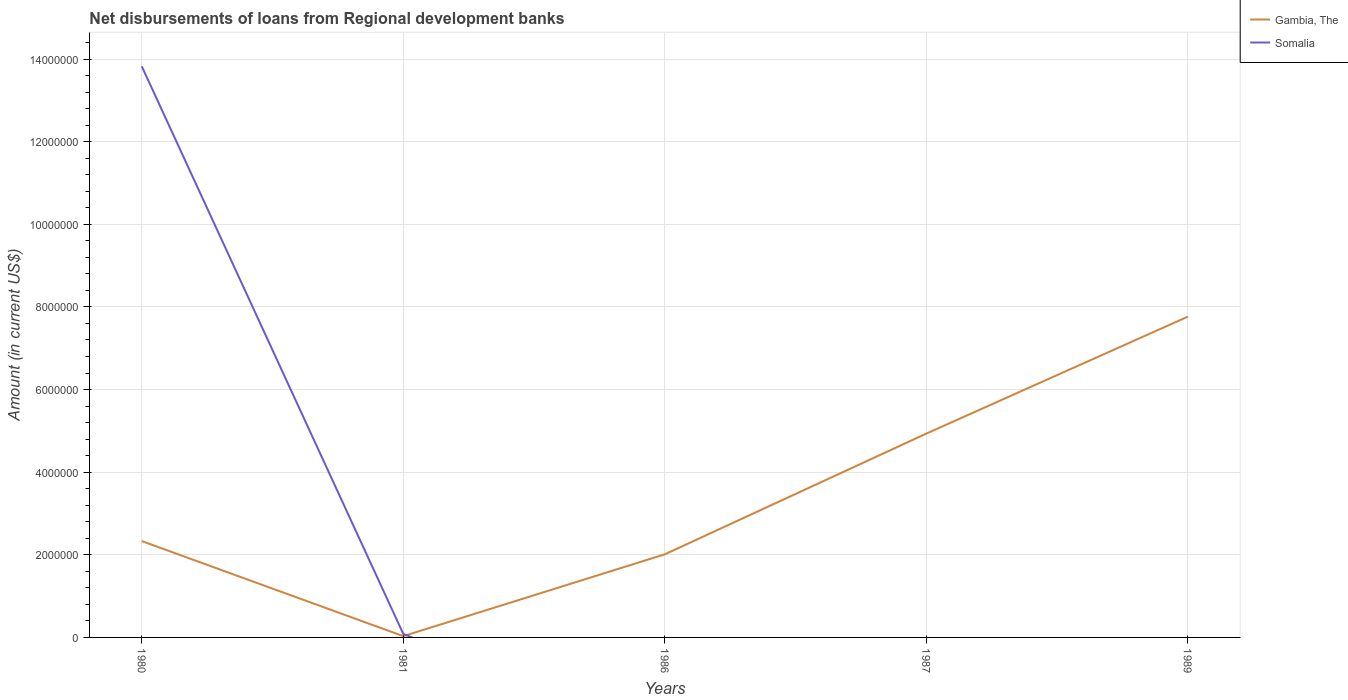How many different coloured lines are there?
Provide a short and direct response. 2. Does the line corresponding to Gambia, The intersect with the line corresponding to Somalia?
Your response must be concise. Yes. Is the number of lines equal to the number of legend labels?
Offer a terse response. No. Across all years, what is the maximum amount of disbursements of loans from regional development banks in Gambia, The?
Give a very brief answer. 3.10e+04. What is the total amount of disbursements of loans from regional development banks in Gambia, The in the graph?
Ensure brevity in your answer.  -2.83e+06. What is the difference between the highest and the second highest amount of disbursements of loans from regional development banks in Gambia, The?
Provide a succinct answer. 7.73e+06. Is the amount of disbursements of loans from regional development banks in Gambia, The strictly greater than the amount of disbursements of loans from regional development banks in Somalia over the years?
Offer a terse response. No. How many lines are there?
Your answer should be compact. 2. What is the difference between two consecutive major ticks on the Y-axis?
Your answer should be compact. 2.00e+06. Are the values on the major ticks of Y-axis written in scientific E-notation?
Offer a very short reply. No. Does the graph contain grids?
Ensure brevity in your answer.  Yes. Where does the legend appear in the graph?
Ensure brevity in your answer.  Top right. How are the legend labels stacked?
Keep it short and to the point. Vertical. What is the title of the graph?
Your answer should be compact. Net disbursements of loans from Regional development banks. What is the label or title of the X-axis?
Offer a very short reply. Years. What is the Amount (in current US$) of Gambia, The in 1980?
Give a very brief answer. 2.33e+06. What is the Amount (in current US$) of Somalia in 1980?
Offer a terse response. 1.38e+07. What is the Amount (in current US$) in Gambia, The in 1981?
Your response must be concise. 3.10e+04. What is the Amount (in current US$) of Somalia in 1981?
Ensure brevity in your answer.  8.50e+04. What is the Amount (in current US$) of Gambia, The in 1986?
Offer a terse response. 2.01e+06. What is the Amount (in current US$) in Somalia in 1986?
Keep it short and to the point. 0. What is the Amount (in current US$) of Gambia, The in 1987?
Make the answer very short. 4.93e+06. What is the Amount (in current US$) of Gambia, The in 1989?
Offer a terse response. 7.76e+06. What is the Amount (in current US$) of Somalia in 1989?
Offer a terse response. 0. Across all years, what is the maximum Amount (in current US$) of Gambia, The?
Keep it short and to the point. 7.76e+06. Across all years, what is the maximum Amount (in current US$) of Somalia?
Give a very brief answer. 1.38e+07. Across all years, what is the minimum Amount (in current US$) in Gambia, The?
Keep it short and to the point. 3.10e+04. What is the total Amount (in current US$) of Gambia, The in the graph?
Offer a very short reply. 1.71e+07. What is the total Amount (in current US$) of Somalia in the graph?
Give a very brief answer. 1.39e+07. What is the difference between the Amount (in current US$) in Gambia, The in 1980 and that in 1981?
Ensure brevity in your answer.  2.30e+06. What is the difference between the Amount (in current US$) in Somalia in 1980 and that in 1981?
Keep it short and to the point. 1.37e+07. What is the difference between the Amount (in current US$) in Gambia, The in 1980 and that in 1986?
Ensure brevity in your answer.  3.20e+05. What is the difference between the Amount (in current US$) in Gambia, The in 1980 and that in 1987?
Your answer should be very brief. -2.60e+06. What is the difference between the Amount (in current US$) of Gambia, The in 1980 and that in 1989?
Give a very brief answer. -5.43e+06. What is the difference between the Amount (in current US$) in Gambia, The in 1981 and that in 1986?
Ensure brevity in your answer.  -1.98e+06. What is the difference between the Amount (in current US$) of Gambia, The in 1981 and that in 1987?
Offer a terse response. -4.90e+06. What is the difference between the Amount (in current US$) in Gambia, The in 1981 and that in 1989?
Make the answer very short. -7.73e+06. What is the difference between the Amount (in current US$) of Gambia, The in 1986 and that in 1987?
Provide a short and direct response. -2.92e+06. What is the difference between the Amount (in current US$) in Gambia, The in 1986 and that in 1989?
Your response must be concise. -5.75e+06. What is the difference between the Amount (in current US$) of Gambia, The in 1987 and that in 1989?
Provide a short and direct response. -2.83e+06. What is the difference between the Amount (in current US$) in Gambia, The in 1980 and the Amount (in current US$) in Somalia in 1981?
Ensure brevity in your answer.  2.25e+06. What is the average Amount (in current US$) of Gambia, The per year?
Ensure brevity in your answer.  3.41e+06. What is the average Amount (in current US$) of Somalia per year?
Offer a very short reply. 2.78e+06. In the year 1980, what is the difference between the Amount (in current US$) in Gambia, The and Amount (in current US$) in Somalia?
Offer a terse response. -1.15e+07. In the year 1981, what is the difference between the Amount (in current US$) in Gambia, The and Amount (in current US$) in Somalia?
Provide a short and direct response. -5.40e+04. What is the ratio of the Amount (in current US$) of Gambia, The in 1980 to that in 1981?
Give a very brief answer. 75.23. What is the ratio of the Amount (in current US$) in Somalia in 1980 to that in 1981?
Your answer should be compact. 162.64. What is the ratio of the Amount (in current US$) in Gambia, The in 1980 to that in 1986?
Give a very brief answer. 1.16. What is the ratio of the Amount (in current US$) of Gambia, The in 1980 to that in 1987?
Your response must be concise. 0.47. What is the ratio of the Amount (in current US$) in Gambia, The in 1980 to that in 1989?
Make the answer very short. 0.3. What is the ratio of the Amount (in current US$) of Gambia, The in 1981 to that in 1986?
Your answer should be compact. 0.02. What is the ratio of the Amount (in current US$) in Gambia, The in 1981 to that in 1987?
Your answer should be compact. 0.01. What is the ratio of the Amount (in current US$) in Gambia, The in 1981 to that in 1989?
Your answer should be compact. 0. What is the ratio of the Amount (in current US$) in Gambia, The in 1986 to that in 1987?
Offer a very short reply. 0.41. What is the ratio of the Amount (in current US$) in Gambia, The in 1986 to that in 1989?
Provide a succinct answer. 0.26. What is the ratio of the Amount (in current US$) in Gambia, The in 1987 to that in 1989?
Your answer should be compact. 0.64. What is the difference between the highest and the second highest Amount (in current US$) in Gambia, The?
Provide a short and direct response. 2.83e+06. What is the difference between the highest and the lowest Amount (in current US$) in Gambia, The?
Keep it short and to the point. 7.73e+06. What is the difference between the highest and the lowest Amount (in current US$) in Somalia?
Your answer should be compact. 1.38e+07. 